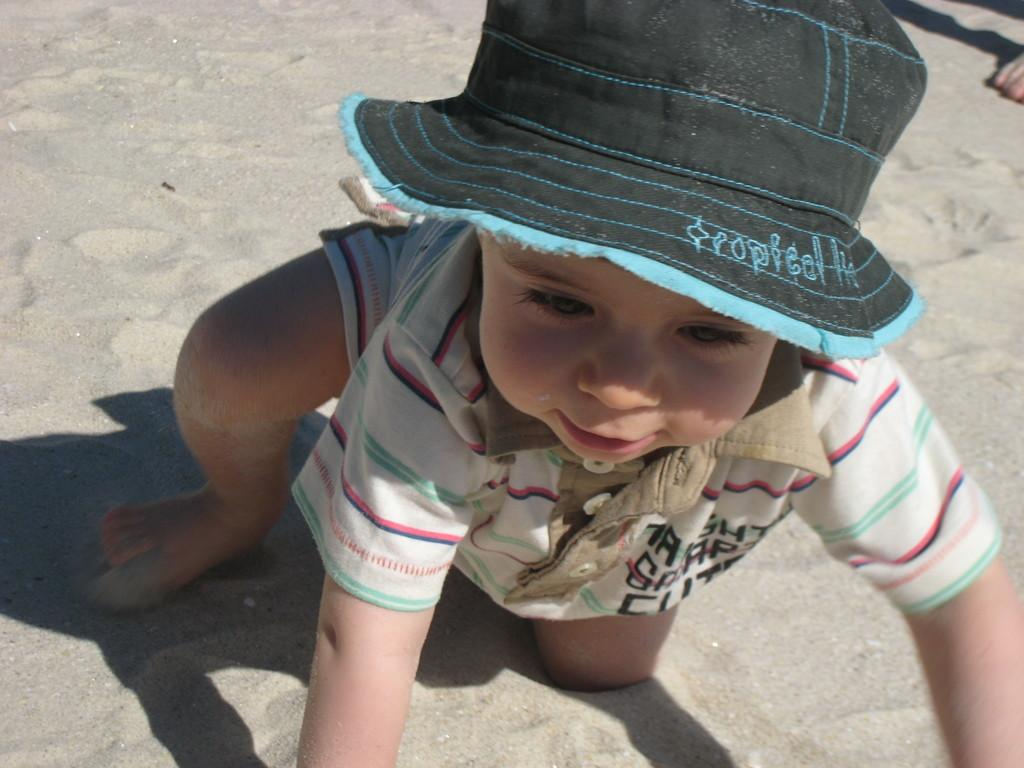Who is the main subject in the picture? There is a boy in the picture. What is the boy wearing on his head? The boy is wearing a cap. What type of terrain is visible in the picture? There is sand on the ground in the picture. Can you describe any other body parts visible in the image? A human leg is visible in the image. What type of van is parked next to the boy in the image? There is no van present in the image. How many fingers can be seen on the boy's hand in the image? The image does not show the boy's hand, so it is not possible to determine the number of fingers. 